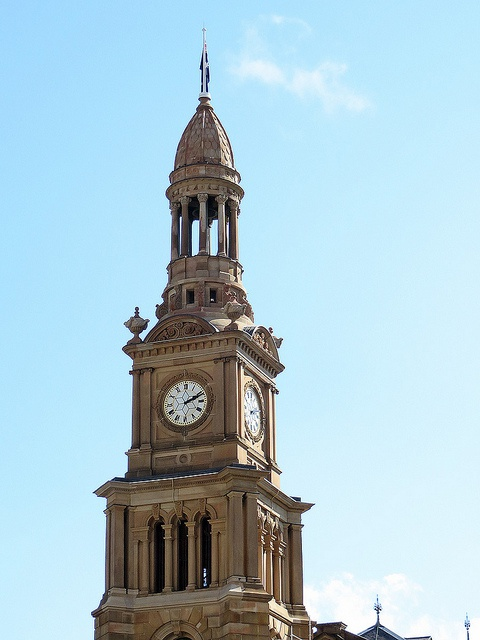Describe the objects in this image and their specific colors. I can see clock in lightblue, darkgray, black, and gray tones and clock in lightblue, white, darkgray, gray, and tan tones in this image. 